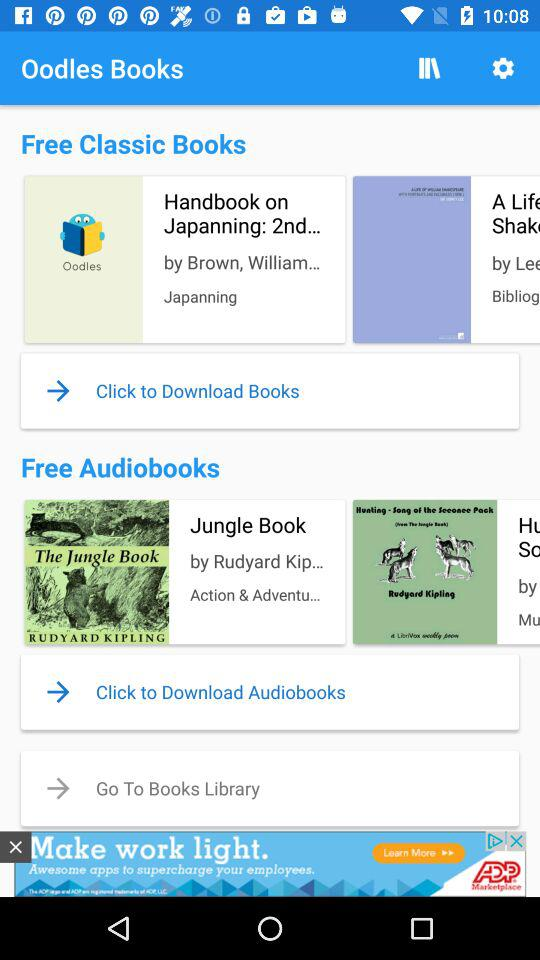What is the name of the application? The name of the application is "Oodles Books". 